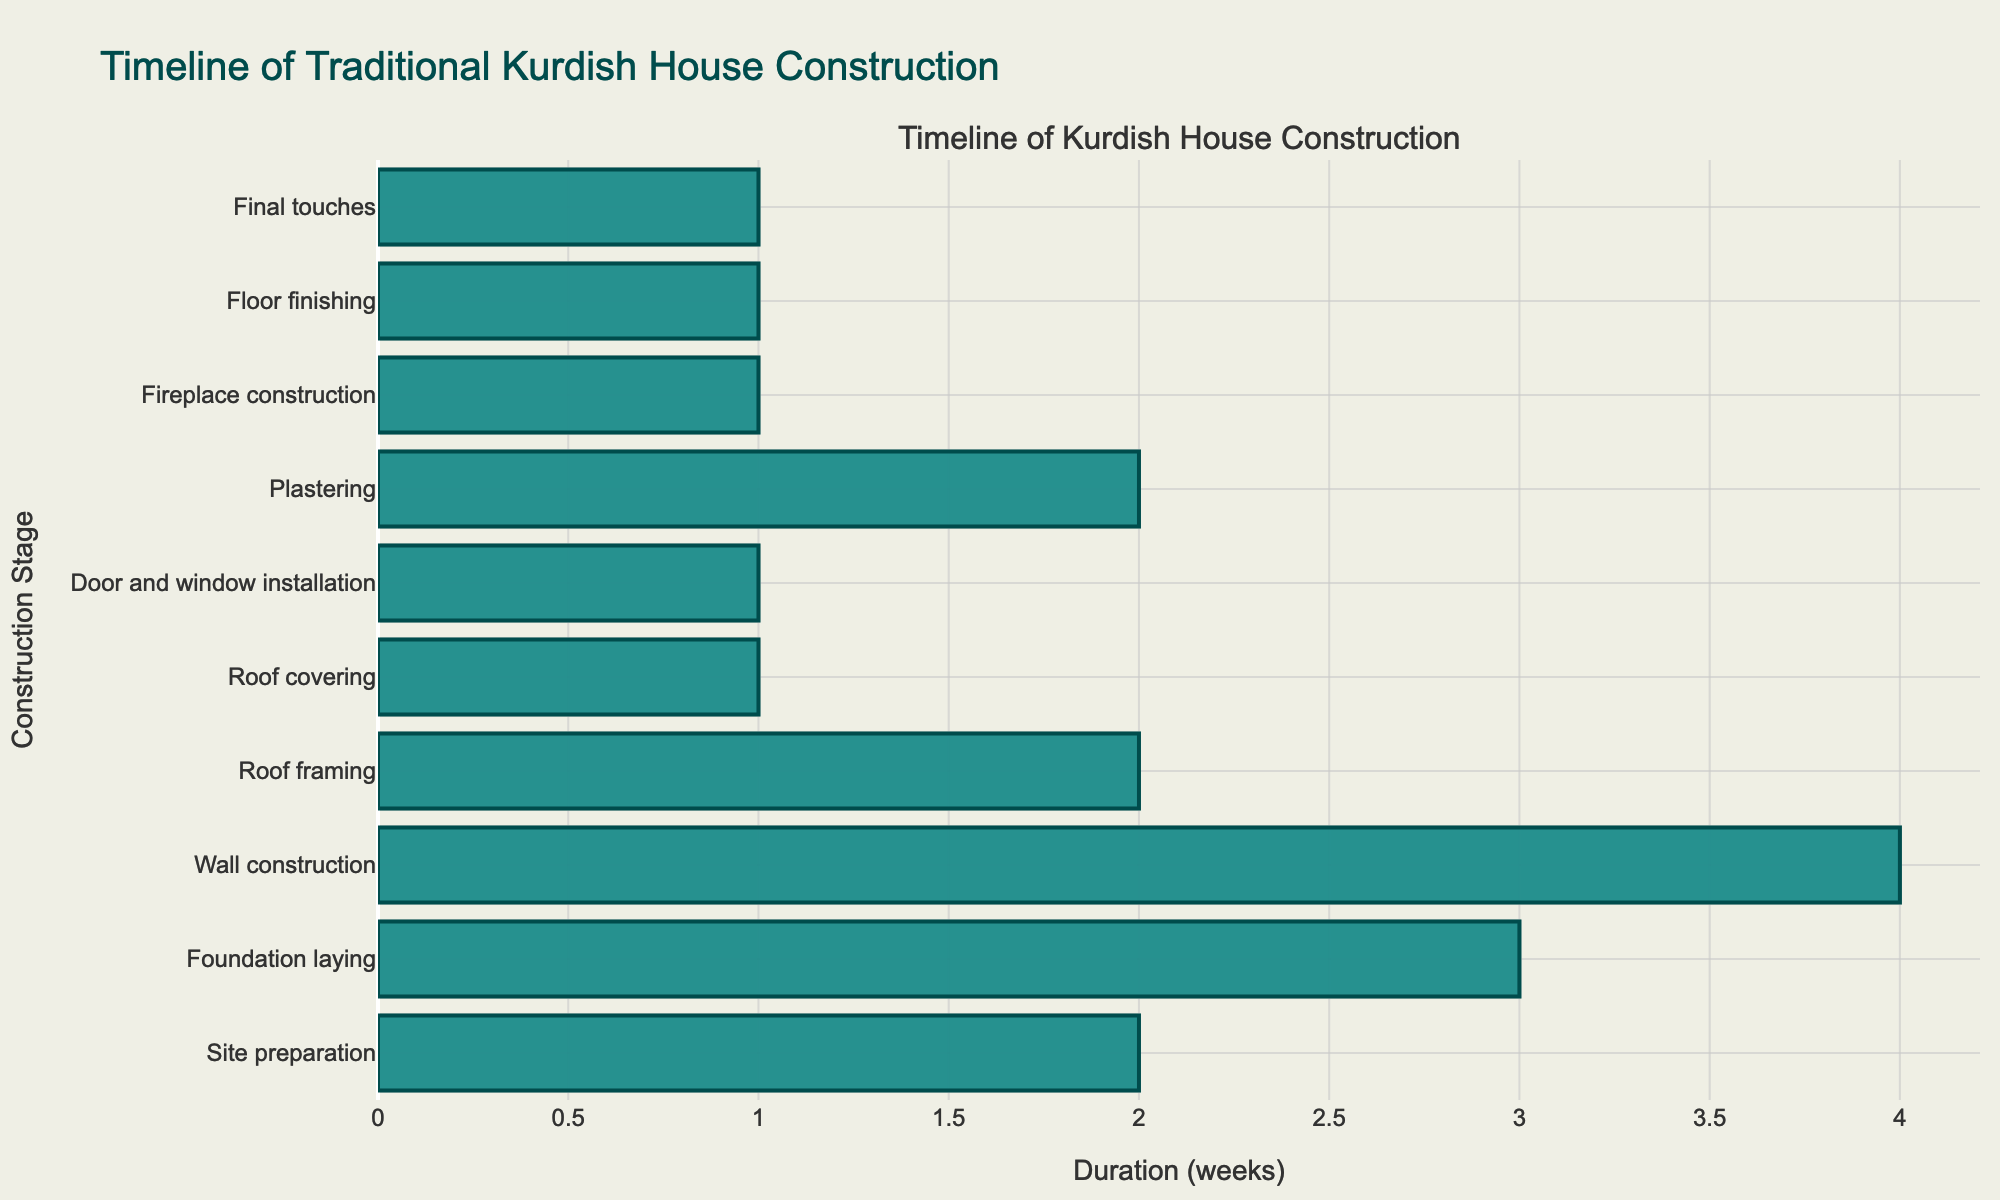What is the duration of the wall construction? According to the table, the duration for wall construction is specifically listed under the "Duration (weeks)" column corresponding to the "Wall construction" stage, which is 4 weeks.
Answer: 4 weeks Who is responsible for the roof covering? The table identifies the person responsible for the roof covering in the "Responsible Person" column, where it states that "Family members" are tasked with applying the mud and straw mixture for insulation.
Answer: Family members What is the total duration of the construction stages that involve family members? First, we identify the stages that involve family members: Roof covering (1 week) and Floor finishing (1 week). Summing these gives us 1 + 1 = 2 weeks.
Answer: 2 weeks Is the plastering stage longer than the fireplace construction stage? By comparing the durations in the table, plastering takes 2 weeks, while fireplace construction takes 1 week. Since 2 weeks is greater than 1 week, the plastering stage is indeed longer.
Answer: Yes How many weeks are spent on the foundation laying and wall construction combined? We add the durations of foundation laying (3 weeks) and wall construction (4 weeks). Thus, 3 + 4 = 7 weeks in total for these two stages.
Answer: 7 weeks What materials are used for wall construction? The key materials for wall construction can be found in the "Key Materials" column associated with the "Wall construction" stage, which states the materials are mud bricks or local stone.
Answer: Mud bricks or local stone Is the total duration of the construction project more than 10 weeks? To determine this, we sum all the durations: 2 + 3 + 4 + 2 + 1 + 1 + 2 + 1 + 1 + 1 = 18 weeks. Since 18 weeks is greater than 10 weeks, the total duration exceeds 10 weeks.
Answer: Yes Who is responsible for the final touches, and what materials do they use? Referring to the "Responsible Person" and "Key Materials" columns for the "Final touches" stage, it shows that the responsible person is Nazdar the village artist and the materials are natural pigments and local textiles.
Answer: Nazdar the village artist; natural pigments and local textiles What is the difference in duration between roof framing and door/window installation? Roof framing takes 2 weeks while door/window installation takes 1 week. The difference is 2 - 1 = 1 week.
Answer: 1 week 